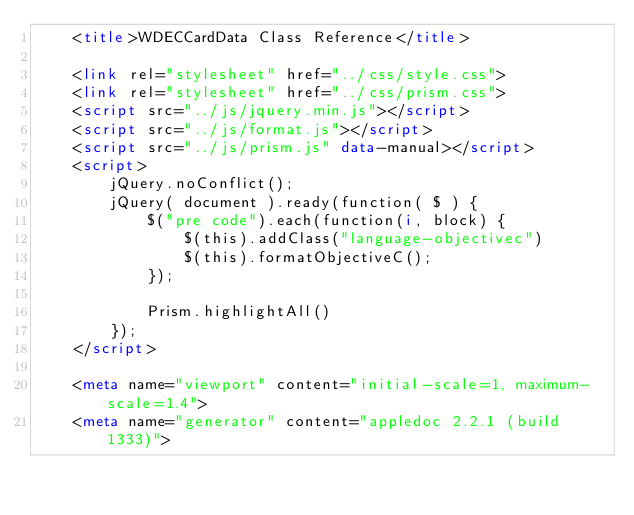<code> <loc_0><loc_0><loc_500><loc_500><_HTML_>	<title>WDECCardData Class Reference</title>

	<link rel="stylesheet" href="../css/style.css">
	<link rel="stylesheet" href="../css/prism.css">
	<script src="../js/jquery.min.js"></script>
	<script src="../js/format.js"></script>
	<script src="../js/prism.js" data-manual></script>
	<script>
		jQuery.noConflict();
		jQuery( document ).ready(function( $ ) {
 			$("pre code").each(function(i, block) {
				$(this).addClass("language-objectivec")
				$(this).formatObjectiveC();
			});

			Prism.highlightAll()
		});
	</script>

	<meta name="viewport" content="initial-scale=1, maximum-scale=1.4">
	<meta name="generator" content="appledoc 2.2.1 (build 1333)"></code> 